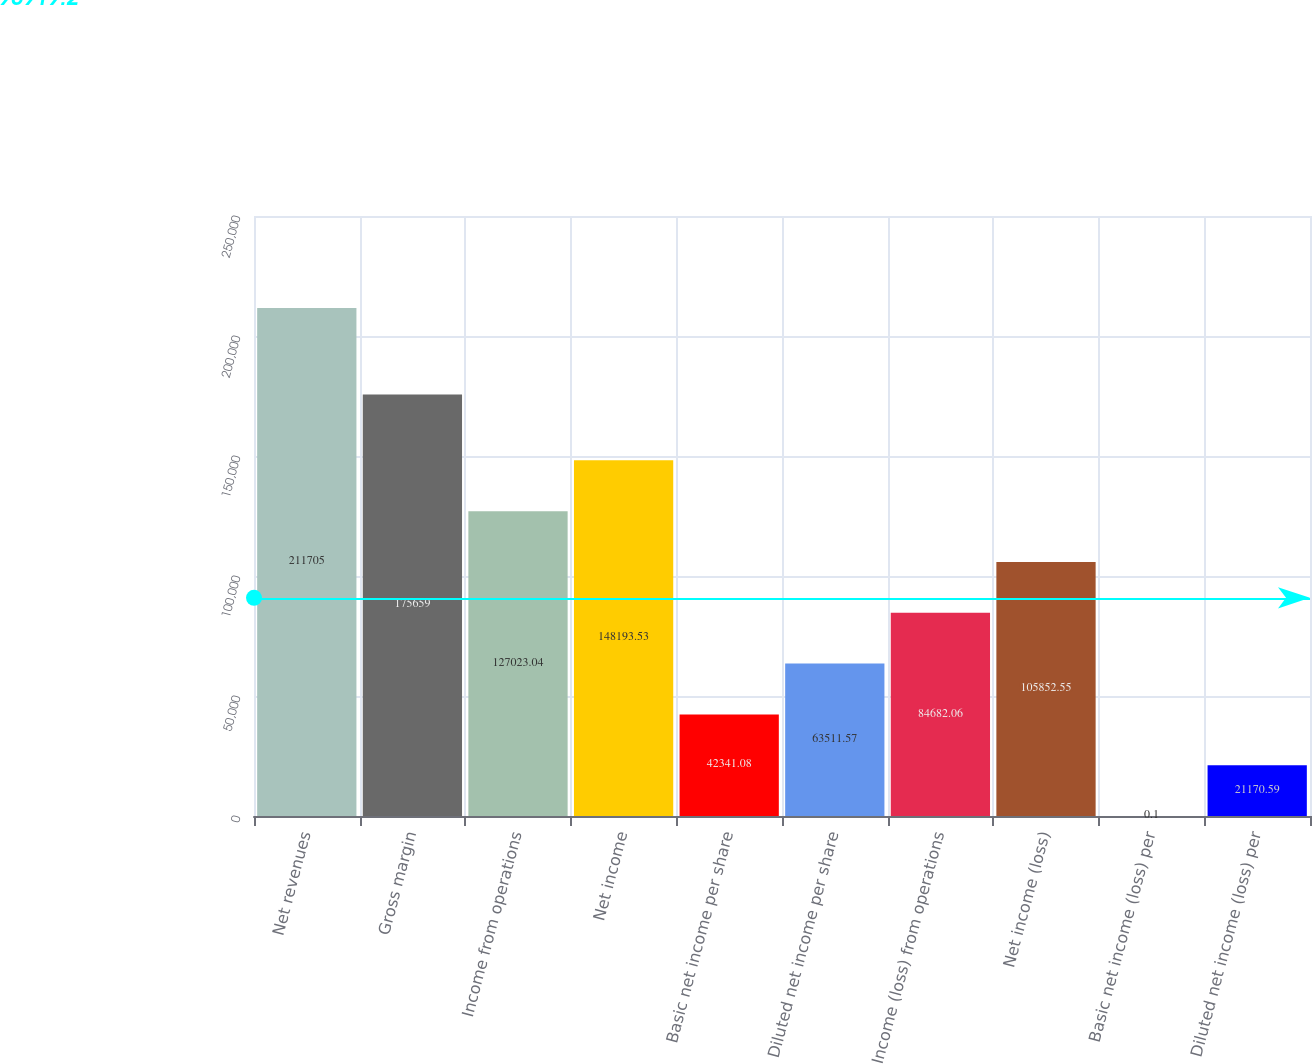<chart> <loc_0><loc_0><loc_500><loc_500><bar_chart><fcel>Net revenues<fcel>Gross margin<fcel>Income from operations<fcel>Net income<fcel>Basic net income per share<fcel>Diluted net income per share<fcel>Income (loss) from operations<fcel>Net income (loss)<fcel>Basic net income (loss) per<fcel>Diluted net income (loss) per<nl><fcel>211705<fcel>175659<fcel>127023<fcel>148194<fcel>42341.1<fcel>63511.6<fcel>84682.1<fcel>105853<fcel>0.1<fcel>21170.6<nl></chart> 